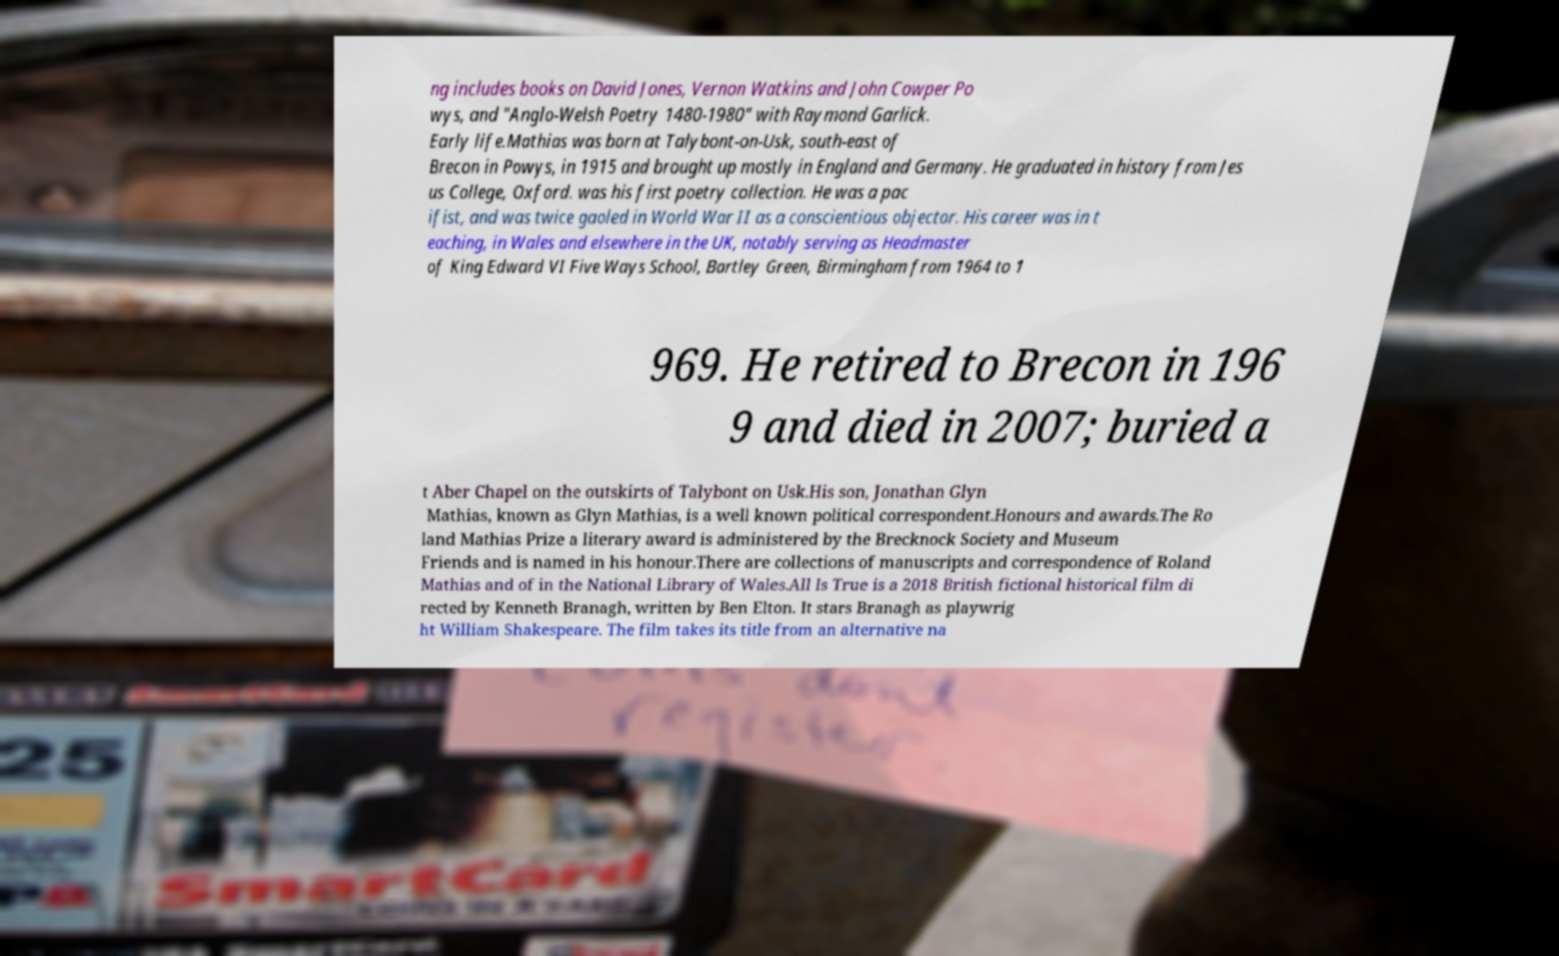Could you extract and type out the text from this image? ng includes books on David Jones, Vernon Watkins and John Cowper Po wys, and "Anglo-Welsh Poetry 1480-1980" with Raymond Garlick. Early life.Mathias was born at Talybont-on-Usk, south-east of Brecon in Powys, in 1915 and brought up mostly in England and Germany. He graduated in history from Jes us College, Oxford. was his first poetry collection. He was a pac ifist, and was twice gaoled in World War II as a conscientious objector. His career was in t eaching, in Wales and elsewhere in the UK, notably serving as Headmaster of King Edward VI Five Ways School, Bartley Green, Birmingham from 1964 to 1 969. He retired to Brecon in 196 9 and died in 2007; buried a t Aber Chapel on the outskirts of Talybont on Usk.His son, Jonathan Glyn Mathias, known as Glyn Mathias, is a well known political correspondent.Honours and awards.The Ro land Mathias Prize a literary award is administered by the Brecknock Society and Museum Friends and is named in his honour.There are collections of manuscripts and correspondence of Roland Mathias and of in the National Library of Wales.All Is True is a 2018 British fictional historical film di rected by Kenneth Branagh, written by Ben Elton. It stars Branagh as playwrig ht William Shakespeare. The film takes its title from an alternative na 